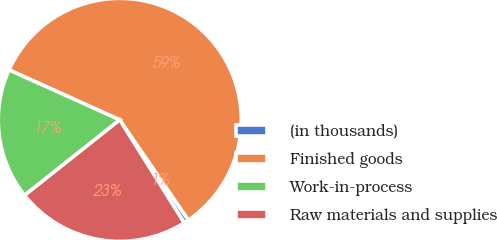Convert chart to OTSL. <chart><loc_0><loc_0><loc_500><loc_500><pie_chart><fcel>(in thousands)<fcel>Finished goods<fcel>Work-in-process<fcel>Raw materials and supplies<nl><fcel>0.66%<fcel>58.69%<fcel>17.42%<fcel>23.23%<nl></chart> 